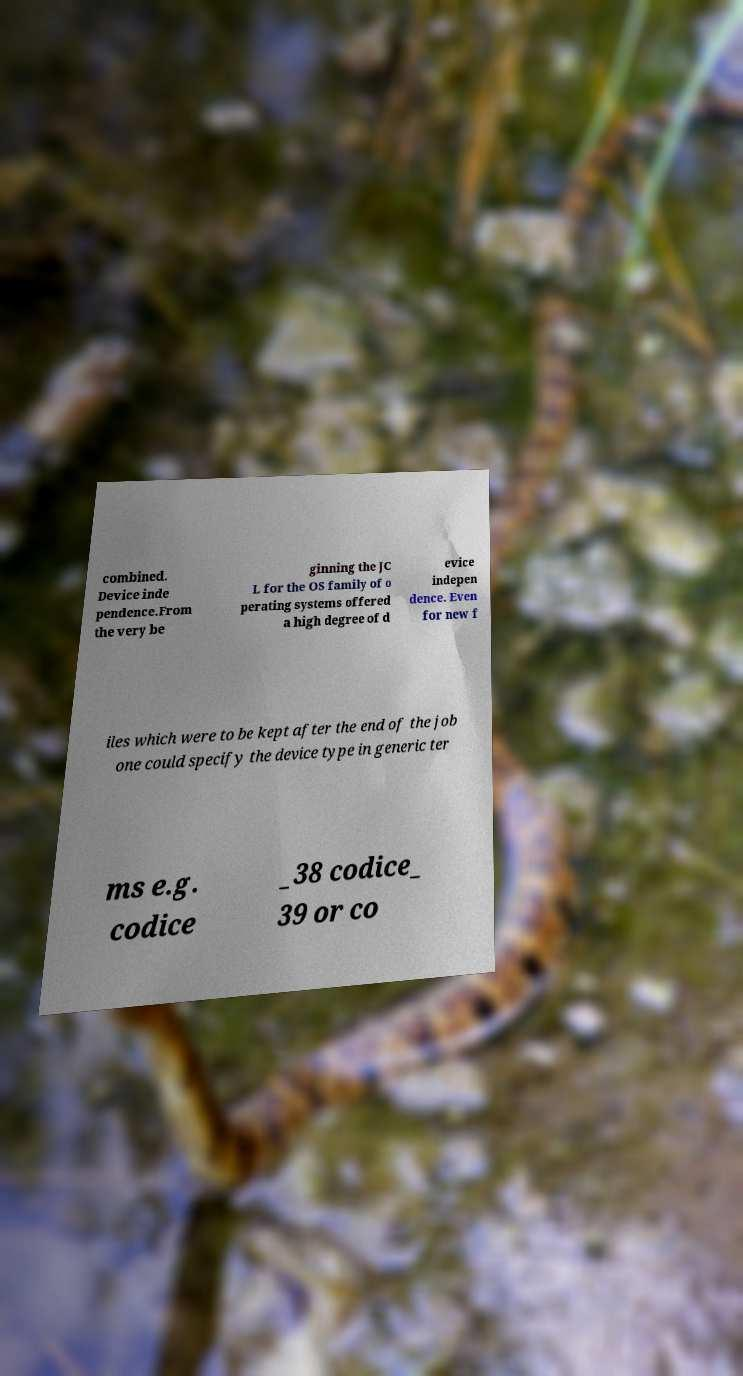Please identify and transcribe the text found in this image. combined. Device inde pendence.From the very be ginning the JC L for the OS family of o perating systems offered a high degree of d evice indepen dence. Even for new f iles which were to be kept after the end of the job one could specify the device type in generic ter ms e.g. codice _38 codice_ 39 or co 